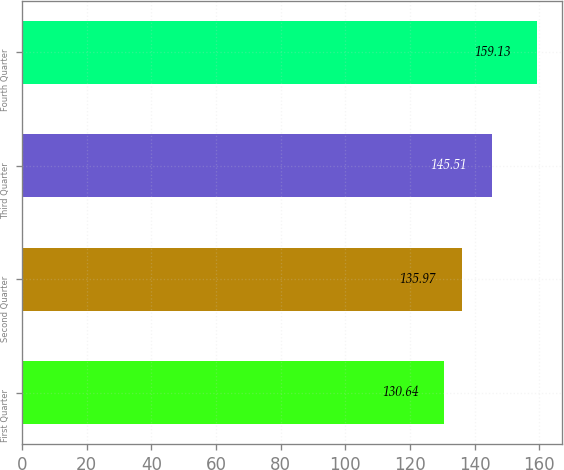Convert chart to OTSL. <chart><loc_0><loc_0><loc_500><loc_500><bar_chart><fcel>First Quarter<fcel>Second Quarter<fcel>Third Quarter<fcel>Fourth Quarter<nl><fcel>130.64<fcel>135.97<fcel>145.51<fcel>159.13<nl></chart> 